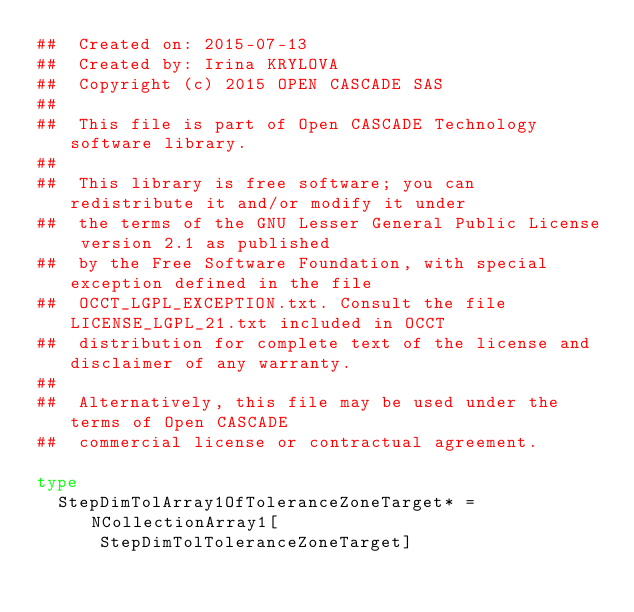<code> <loc_0><loc_0><loc_500><loc_500><_Nim_>##  Created on: 2015-07-13
##  Created by: Irina KRYLOVA
##  Copyright (c) 2015 OPEN CASCADE SAS
##
##  This file is part of Open CASCADE Technology software library.
##
##  This library is free software; you can redistribute it and/or modify it under
##  the terms of the GNU Lesser General Public License version 2.1 as published
##  by the Free Software Foundation, with special exception defined in the file
##  OCCT_LGPL_EXCEPTION.txt. Consult the file LICENSE_LGPL_21.txt included in OCCT
##  distribution for complete text of the license and disclaimer of any warranty.
##
##  Alternatively, this file may be used under the terms of Open CASCADE
##  commercial license or contractual agreement.

type
  StepDimTolArray1OfToleranceZoneTarget* = NCollectionArray1[
      StepDimTolToleranceZoneTarget]
</code> 